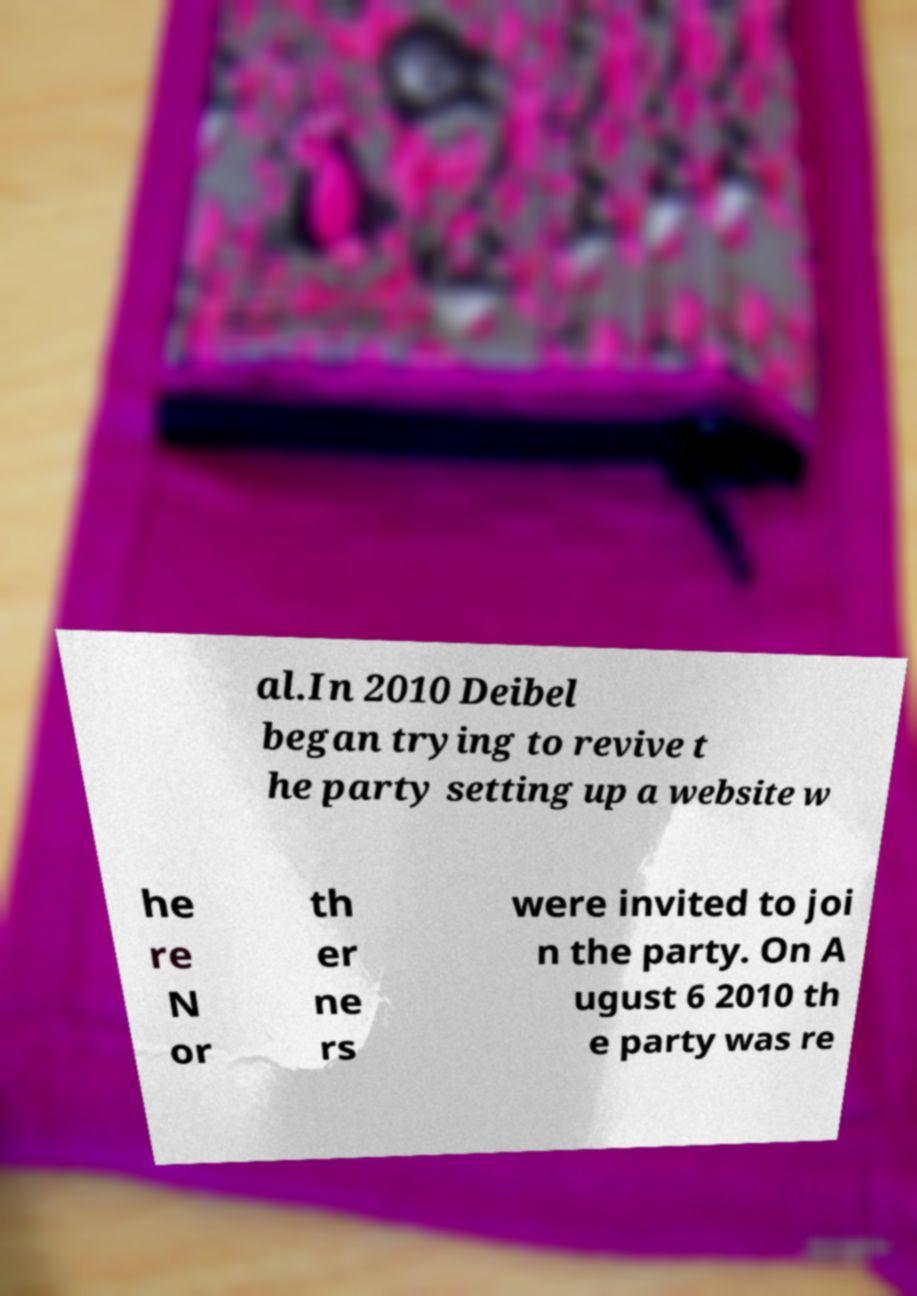I need the written content from this picture converted into text. Can you do that? al.In 2010 Deibel began trying to revive t he party setting up a website w he re N or th er ne rs were invited to joi n the party. On A ugust 6 2010 th e party was re 